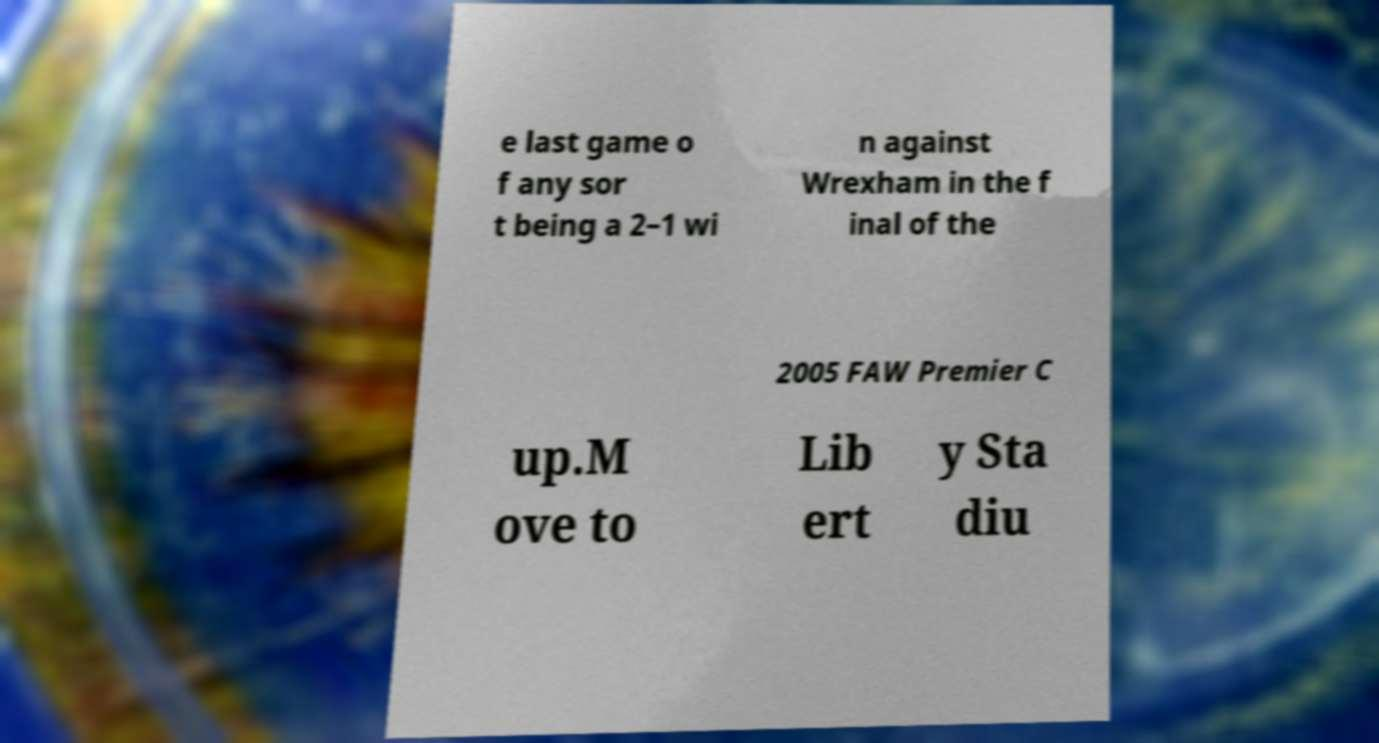Please identify and transcribe the text found in this image. e last game o f any sor t being a 2–1 wi n against Wrexham in the f inal of the 2005 FAW Premier C up.M ove to Lib ert y Sta diu 